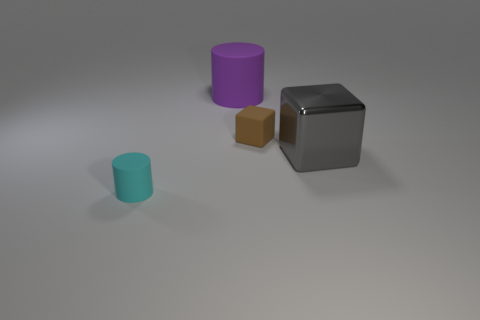What can you infer about the lighting in the scene? The scene is softly lit from above, as evidenced by gentle shadows under the objects, pointing towards a diffuse light source which doesn't cast harsh shadows. How might this lighting affect the mood or use of this image? Soft lighting tends to create a calm, neutral mood. This type of lighting might be used in a setting where the focus is on the objects and their characteristics, such as a product showcase or a comparative analysis. 